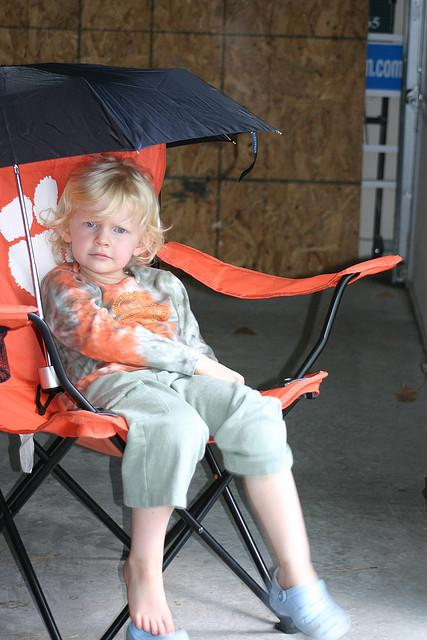What type of footwear is the boy wearing? crocs 